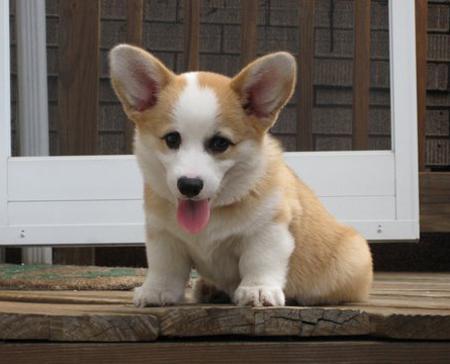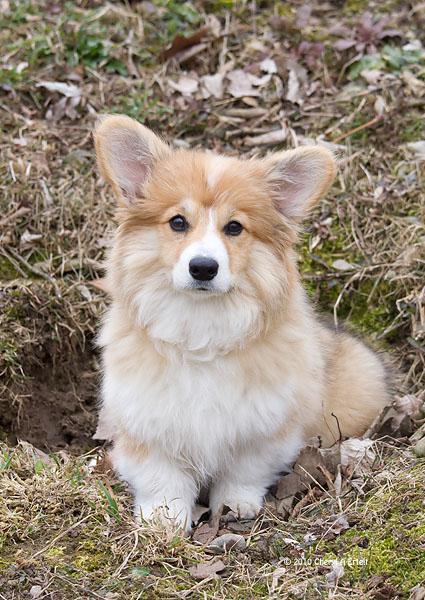The first image is the image on the left, the second image is the image on the right. Assess this claim about the two images: "There are only two dogs and neither of them is wearing a hat.". Correct or not? Answer yes or no. Yes. The first image is the image on the left, the second image is the image on the right. Given the left and right images, does the statement "At least one dog has it's mouth open." hold true? Answer yes or no. Yes. 